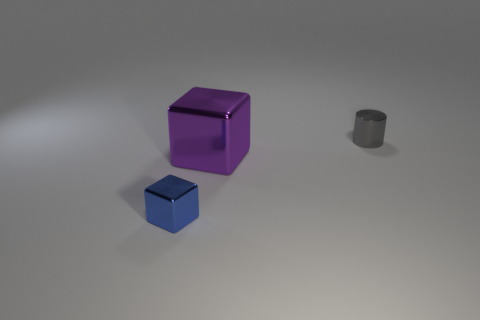Add 2 tiny yellow blocks. How many objects exist? 5 Subtract all cylinders. How many objects are left? 2 Add 1 gray shiny things. How many gray shiny things are left? 2 Add 2 tiny blue cubes. How many tiny blue cubes exist? 3 Subtract 0 brown balls. How many objects are left? 3 Subtract all gray cylinders. Subtract all small gray shiny things. How many objects are left? 1 